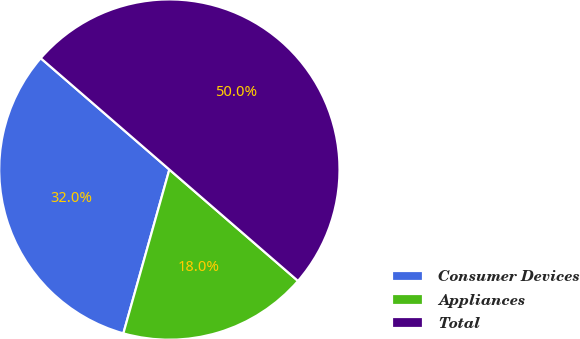Convert chart to OTSL. <chart><loc_0><loc_0><loc_500><loc_500><pie_chart><fcel>Consumer Devices<fcel>Appliances<fcel>Total<nl><fcel>32.0%<fcel>18.0%<fcel>50.0%<nl></chart> 